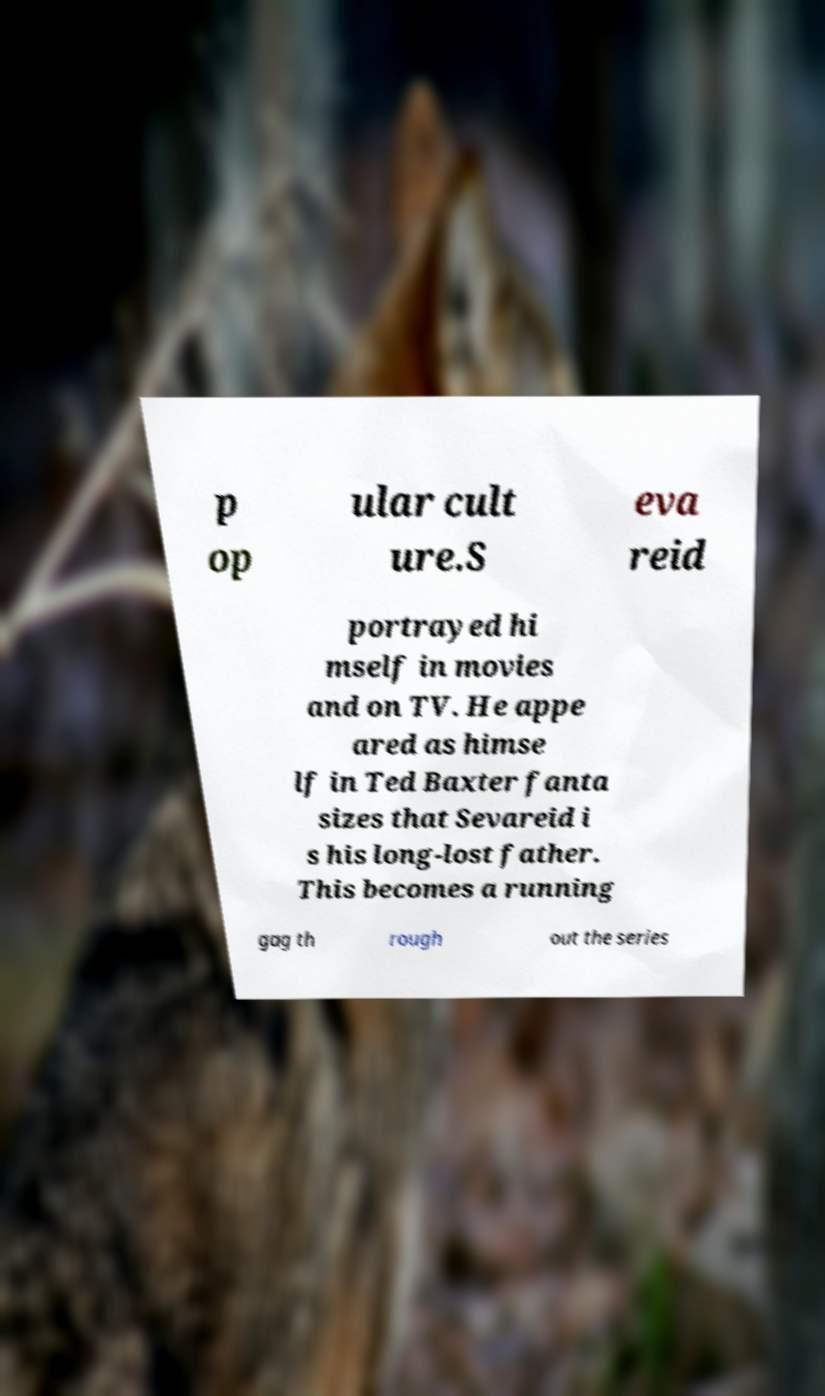Can you accurately transcribe the text from the provided image for me? p op ular cult ure.S eva reid portrayed hi mself in movies and on TV. He appe ared as himse lf in Ted Baxter fanta sizes that Sevareid i s his long-lost father. This becomes a running gag th rough out the series 